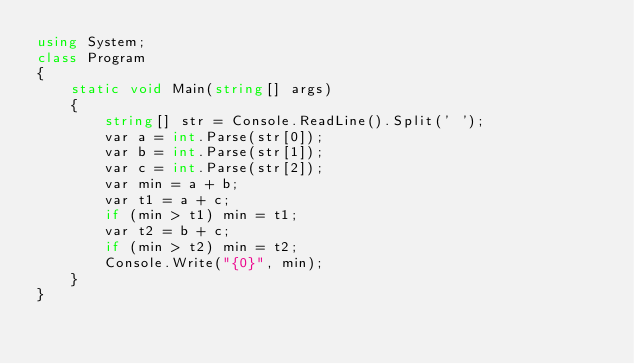Convert code to text. <code><loc_0><loc_0><loc_500><loc_500><_C#_>using System;
class Program
{
    static void Main(string[] args)
    {
        string[] str = Console.ReadLine().Split(' ');
        var a = int.Parse(str[0]);
        var b = int.Parse(str[1]);
        var c = int.Parse(str[2]);
        var min = a + b;
        var t1 = a + c;
        if (min > t1) min = t1;
        var t2 = b + c;
        if (min > t2) min = t2;
        Console.Write("{0}", min);
    }
}</code> 